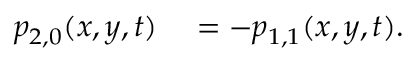Convert formula to latex. <formula><loc_0><loc_0><loc_500><loc_500>\begin{array} { r l } { p _ { 2 , 0 } ( x , y , t ) } & = - p _ { 1 , 1 } ( x , y , t ) . } \end{array}</formula> 